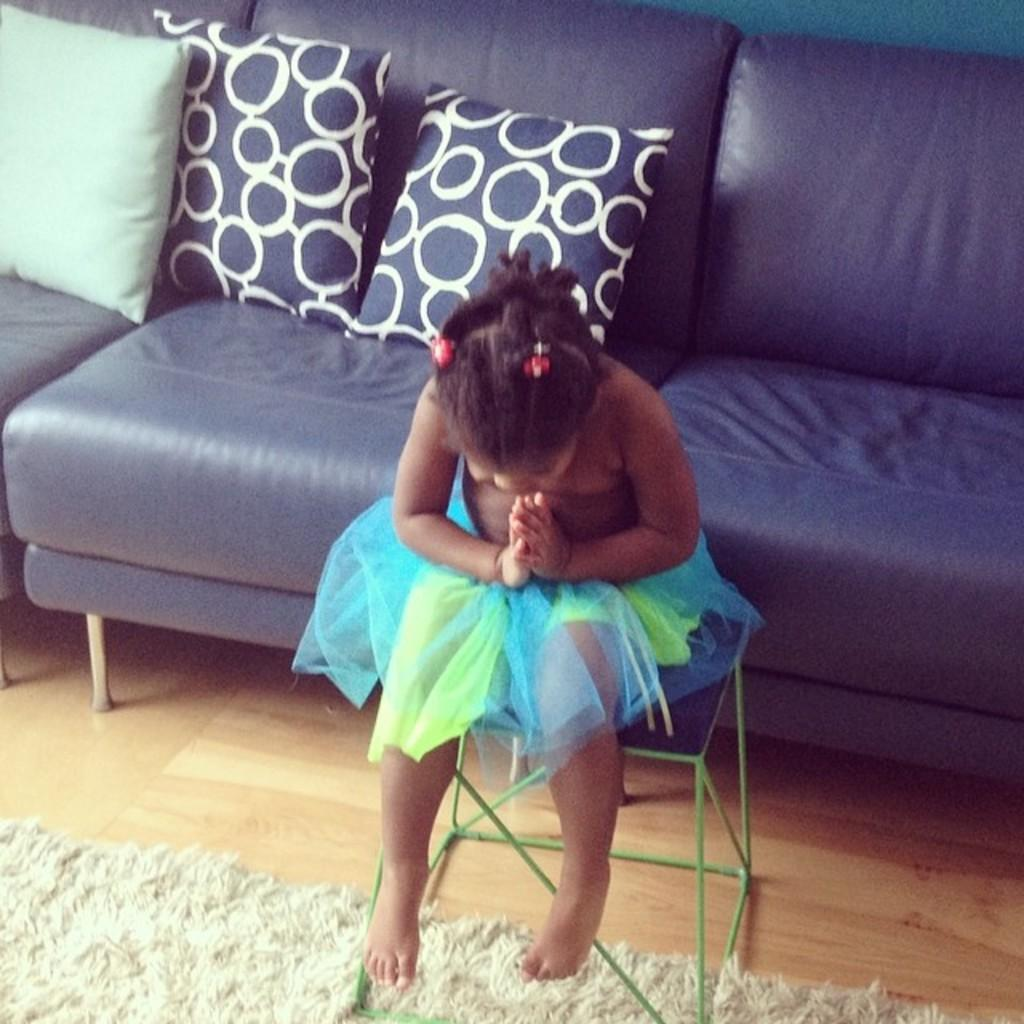What is the person in the image doing? The person is sitting on a table in the image. Which direction is the person facing? The person is facing down. What can be seen behind the table in the image? There is a blue color sofa behind the table. What is on the sofa? There are pillows on the sofa. What is on the ground in the image? There is a carpet on the ground. How long does it take for the lace to untangle in the image? There is no lace present in the image, so it is not possible to determine how long it would take for it to untangle. 